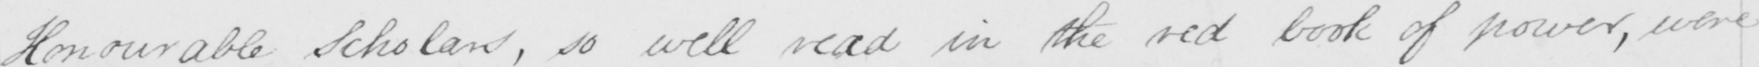Can you read and transcribe this handwriting? Honourable Scholars , so well read in the red book of power , were 